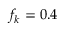Convert formula to latex. <formula><loc_0><loc_0><loc_500><loc_500>f _ { k } = 0 . 4</formula> 